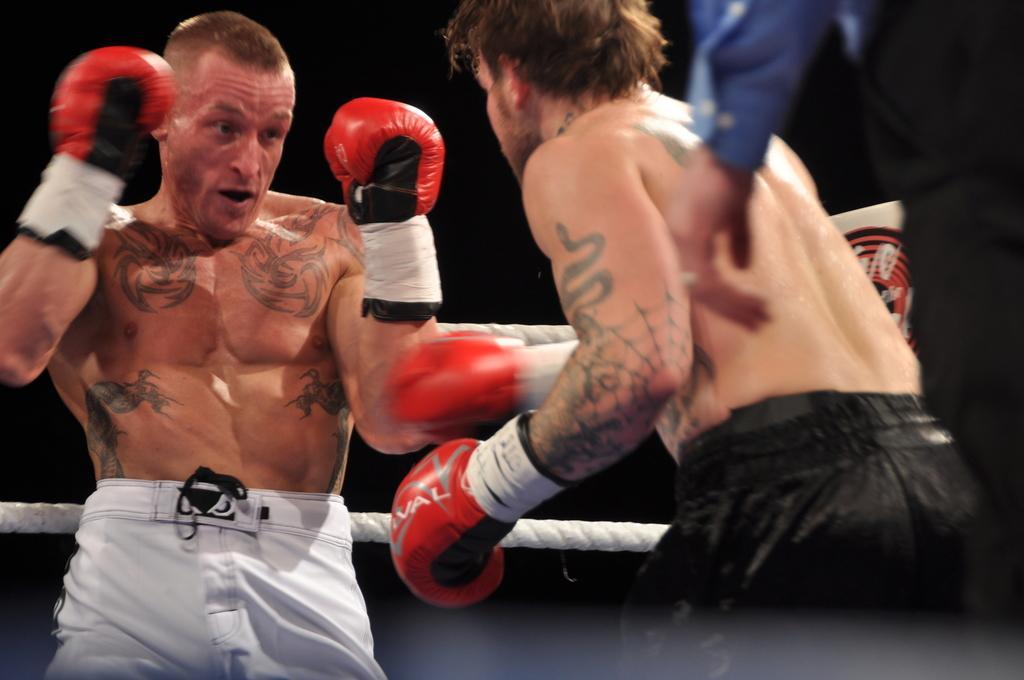Please provide a concise description of this image. Here I can see two men wearing shorts, gloves to the hands and fighting. On the right side, I can see a person's hand. At the back of these people there is a rope. The background is in black color. 